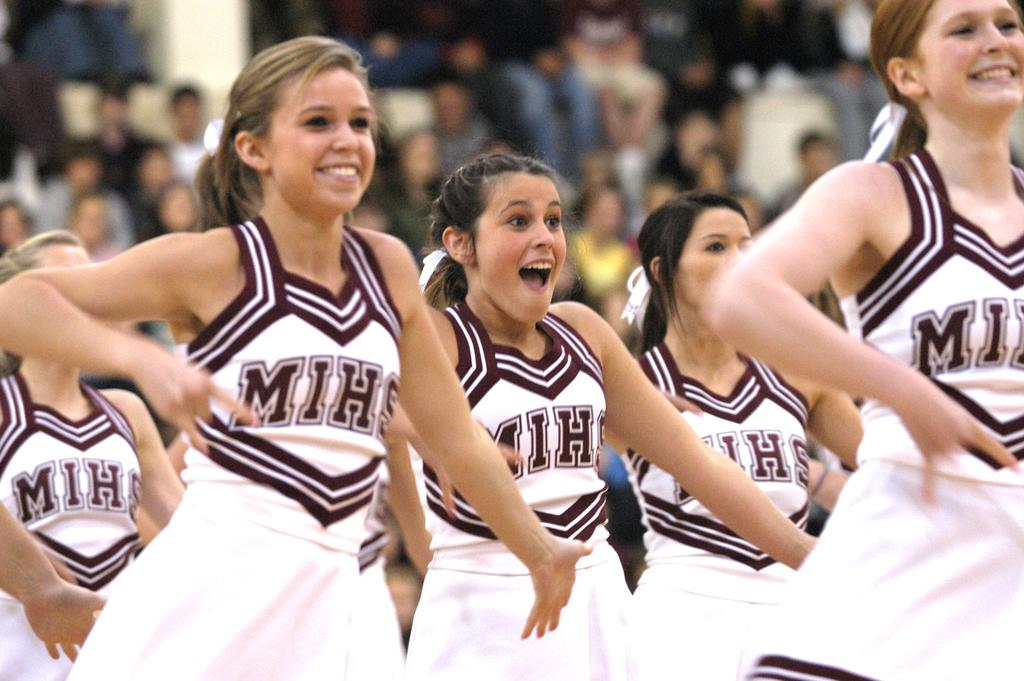<image>
Create a compact narrative representing the image presented. A group of MIHS cheerleaders are doing their routine with smiles on their faces. 